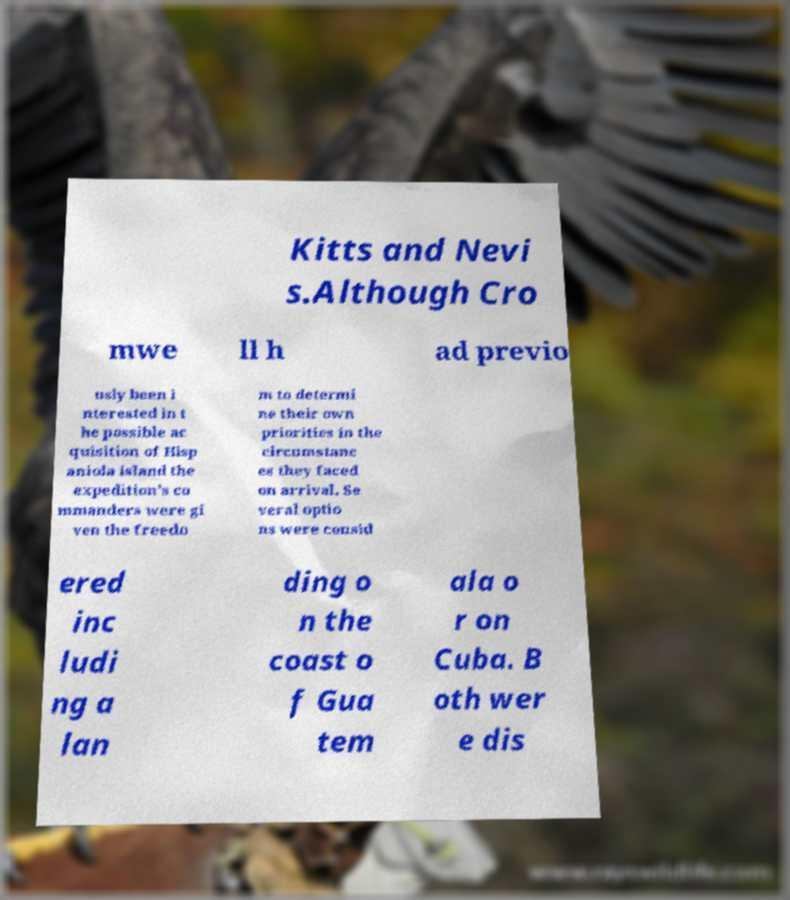I need the written content from this picture converted into text. Can you do that? Kitts and Nevi s.Although Cro mwe ll h ad previo usly been i nterested in t he possible ac quisition of Hisp aniola island the expedition's co mmanders were gi ven the freedo m to determi ne their own priorities in the circumstanc es they faced on arrival. Se veral optio ns were consid ered inc ludi ng a lan ding o n the coast o f Gua tem ala o r on Cuba. B oth wer e dis 